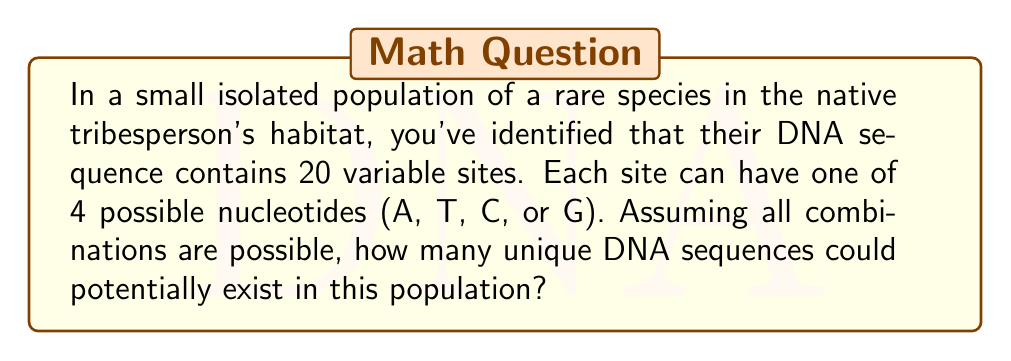Can you answer this question? To solve this problem, we need to use the multiplication principle of counting. Here's the step-by-step explanation:

1) Each variable site in the DNA sequence can have one of 4 possible nucleotides (A, T, C, or G).

2) There are 20 such variable sites.

3) For each site, we have 4 choices, and this is independent of the choices for other sites.

4) Therefore, we need to multiply the number of choices (4) by itself 20 times.

5) Mathematically, this can be represented as:

   $$4^{20}$$

6) This is because we have 4 choices for each of the 20 positions.

7) Calculating this:

   $$4^{20} = 1,099,511,627,776$$

Thus, there are 1,099,511,627,776 possible unique DNA sequences in this population.
Answer: $4^{20} = 1,099,511,627,776$ 